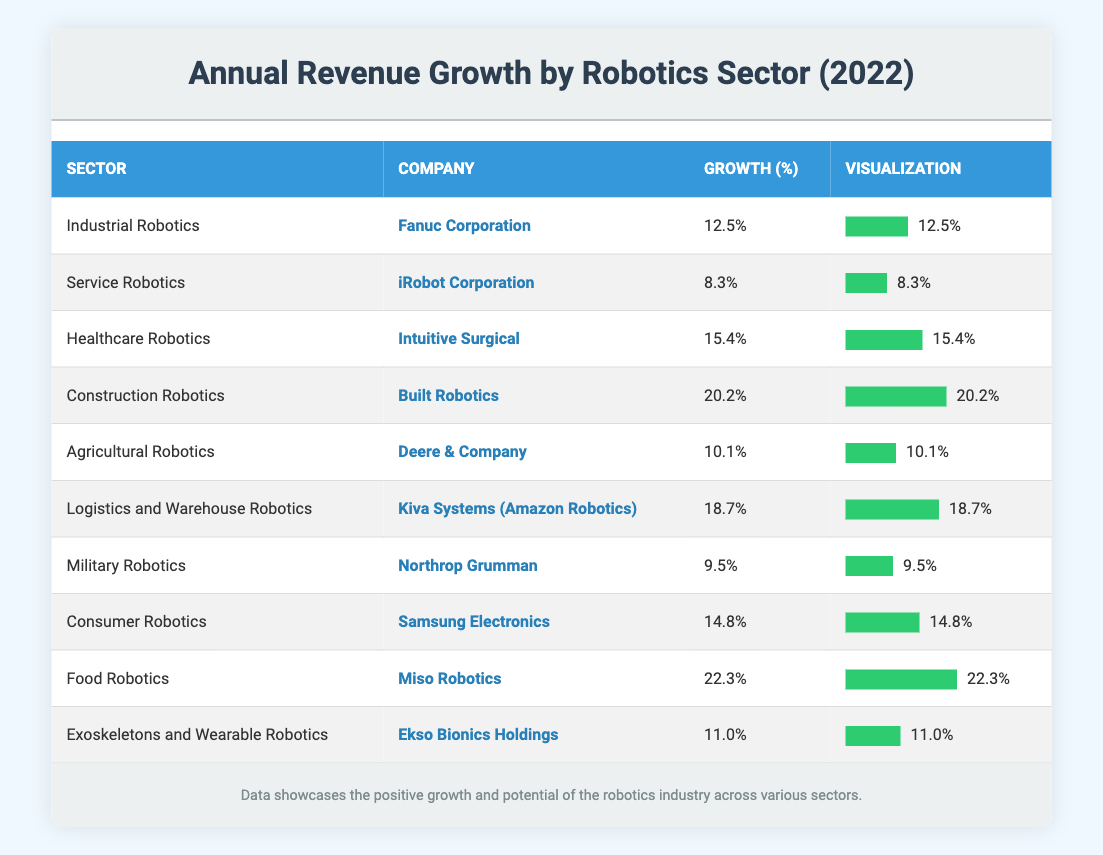What is the company with the highest annual revenue growth in 2022? By examining the table, I can see that "Food Robotics" is associated with "Miso Robotics," which has the highest growth percentage at 22.3%.
Answer: Miso Robotics What sector does Northrop Grumman belong to, and what was its annual revenue growth percentage in 2022? According to the table, Northrop Grumman is in the "Military Robotics" sector, and its annual revenue growth percentage in 2022 was 9.5%.
Answer: Military Robotics, 9.5% Which sector had an annual revenue growth of over 15% in 2022? From the table, I can filter the sectors having growth percentages exceeding 15%, which includes "Healthcare Robotics" at 15.4%, "Construction Robotics" at 20.2%, "Logistics and Warehouse Robotics" at 18.7%, and "Food Robotics" at 22.3%.
Answer: Healthcare Robotics, Construction Robotics, Logistics and Warehouse Robotics, Food Robotics What is the average annual revenue growth percentage for the sectors represented in the table? To calculate the average, I will sum all the growth percentages from the table: (12.5 + 8.3 + 15.4 + 20.2 + 10.1 + 18.7 + 9.5 + 14.8 + 22.3 + 11.0) =  132.8. There are 10 sectors, so the average is 132.8 / 10 = 13.28%.
Answer: 13.28% Is the annual revenue growth of iRobot Corporation greater than that of Fanuc Corporation? By checking the percentages, iRobot Corporation has a growth of 8.3%, while Fanuc Corporation has 12.5%. Since 8.3% is less than 12.5%, the statement is false.
Answer: No Which company from the "Logistics and Warehouse Robotics" sector reported an 18.7% growth? The table indicates that "Kiva Systems (Amazon Robotics)" belongs to the "Logistics and Warehouse Robotics" sector and reported an 18.7% growth.
Answer: Kiva Systems (Amazon Robotics) How many companies reported annual revenue growth percentages between 10% and 15%? I will look at the table and count the companies whose growth percentages fall within this range. They are "Agricultural Robotics" (10.1%), "Exoskeletons and Wearable Robotics" (11.0%), and "Industrial Robotics" (12.5%). This gives us a total of 3 companies.
Answer: 3 Which sector saw the lowest growth percentage among the listed companies in 2022? By reviewing the table, I find that "Service Robotics" (iRobot Corporation) had the lowest reported growth percentage of 8.3%.
Answer: Service Robotics Did any sectors exceed 20% annual revenue growth in 2022? Analyzing the table shows that only the "Food Robotics" sector with Miso Robotics exceeded 20% growth, as it reported a 22.3% growth.
Answer: Yes 